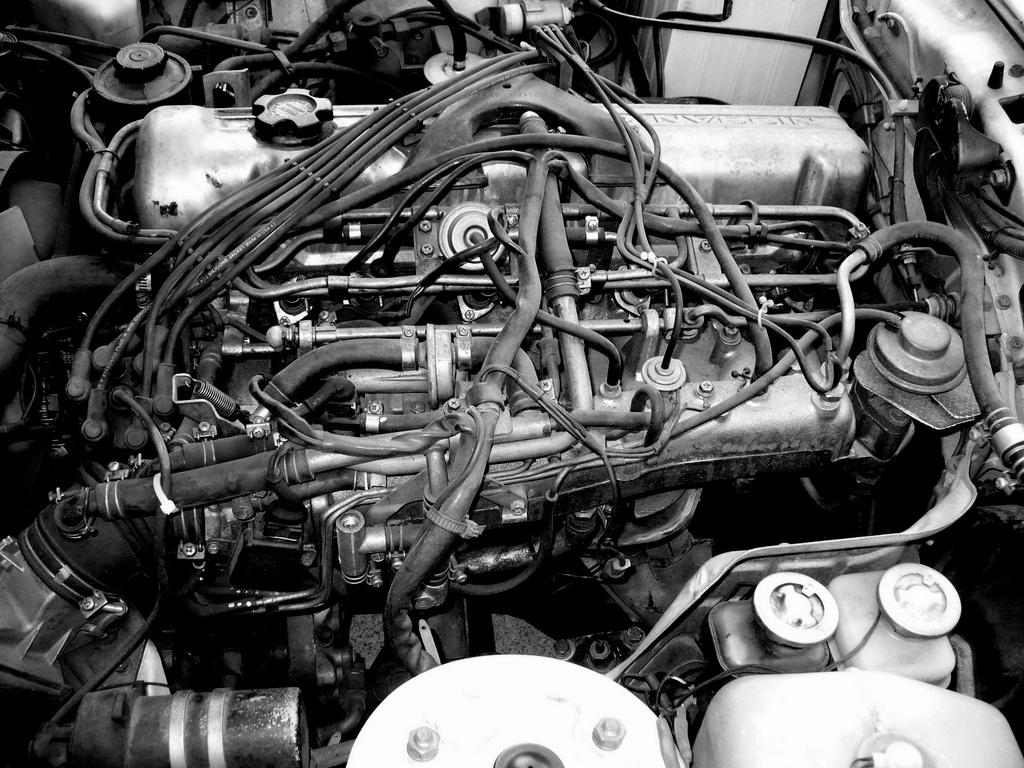What is the main subject of the image? The main subject of the image is an engine. What else can be seen in the image besides the engine? There are cables and parts of a vehicle in the image. How many shelves can be seen in the image? There are no shelves present in the image. What color are the eyes of the vehicle in the image? There are no eyes present in the image, as vehicles do not have eyes. 